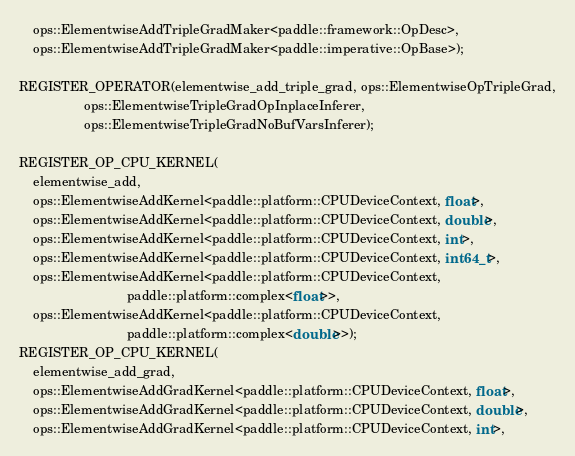Convert code to text. <code><loc_0><loc_0><loc_500><loc_500><_C++_>    ops::ElementwiseAddTripleGradMaker<paddle::framework::OpDesc>,
    ops::ElementwiseAddTripleGradMaker<paddle::imperative::OpBase>);

REGISTER_OPERATOR(elementwise_add_triple_grad, ops::ElementwiseOpTripleGrad,
                  ops::ElementwiseTripleGradOpInplaceInferer,
                  ops::ElementwiseTripleGradNoBufVarsInferer);

REGISTER_OP_CPU_KERNEL(
    elementwise_add,
    ops::ElementwiseAddKernel<paddle::platform::CPUDeviceContext, float>,
    ops::ElementwiseAddKernel<paddle::platform::CPUDeviceContext, double>,
    ops::ElementwiseAddKernel<paddle::platform::CPUDeviceContext, int>,
    ops::ElementwiseAddKernel<paddle::platform::CPUDeviceContext, int64_t>,
    ops::ElementwiseAddKernel<paddle::platform::CPUDeviceContext,
                              paddle::platform::complex<float>>,
    ops::ElementwiseAddKernel<paddle::platform::CPUDeviceContext,
                              paddle::platform::complex<double>>);
REGISTER_OP_CPU_KERNEL(
    elementwise_add_grad,
    ops::ElementwiseAddGradKernel<paddle::platform::CPUDeviceContext, float>,
    ops::ElementwiseAddGradKernel<paddle::platform::CPUDeviceContext, double>,
    ops::ElementwiseAddGradKernel<paddle::platform::CPUDeviceContext, int>,</code> 